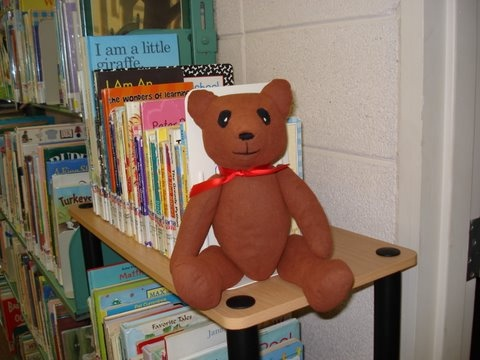Describe the objects in this image and their specific colors. I can see book in darkgreen, gray, black, olive, and darkgray tones, teddy bear in darkgreen, maroon, and brown tones, book in darkgreen, gray, black, and olive tones, book in darkgreen, black, gray, and red tones, and book in darkgreen and teal tones in this image. 